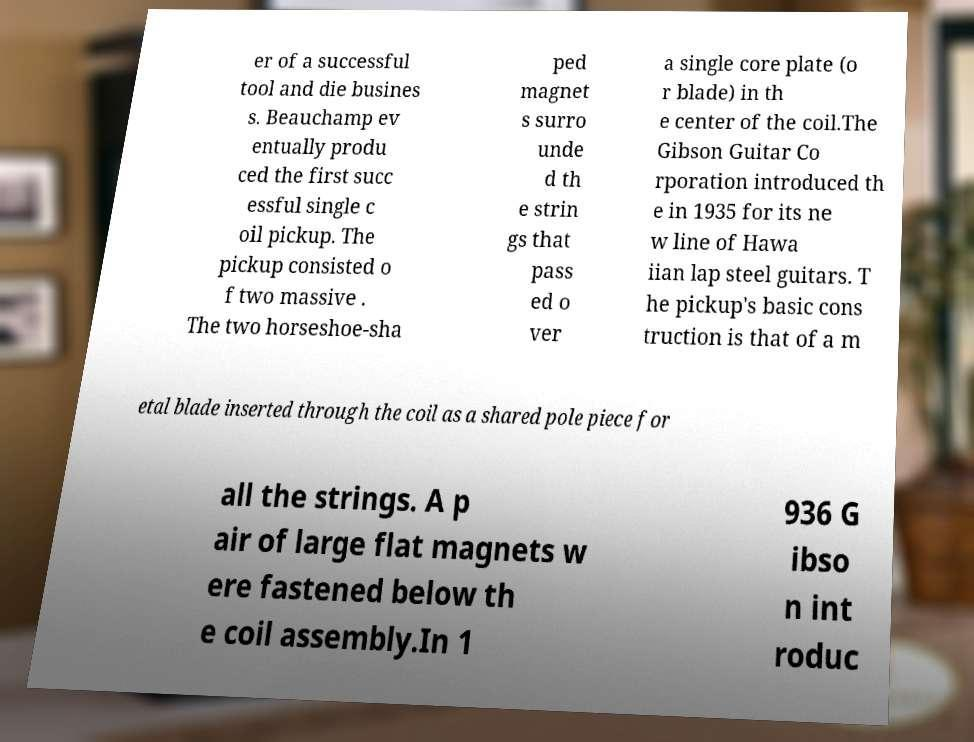For documentation purposes, I need the text within this image transcribed. Could you provide that? er of a successful tool and die busines s. Beauchamp ev entually produ ced the first succ essful single c oil pickup. The pickup consisted o f two massive . The two horseshoe-sha ped magnet s surro unde d th e strin gs that pass ed o ver a single core plate (o r blade) in th e center of the coil.The Gibson Guitar Co rporation introduced th e in 1935 for its ne w line of Hawa iian lap steel guitars. T he pickup's basic cons truction is that of a m etal blade inserted through the coil as a shared pole piece for all the strings. A p air of large flat magnets w ere fastened below th e coil assembly.In 1 936 G ibso n int roduc 